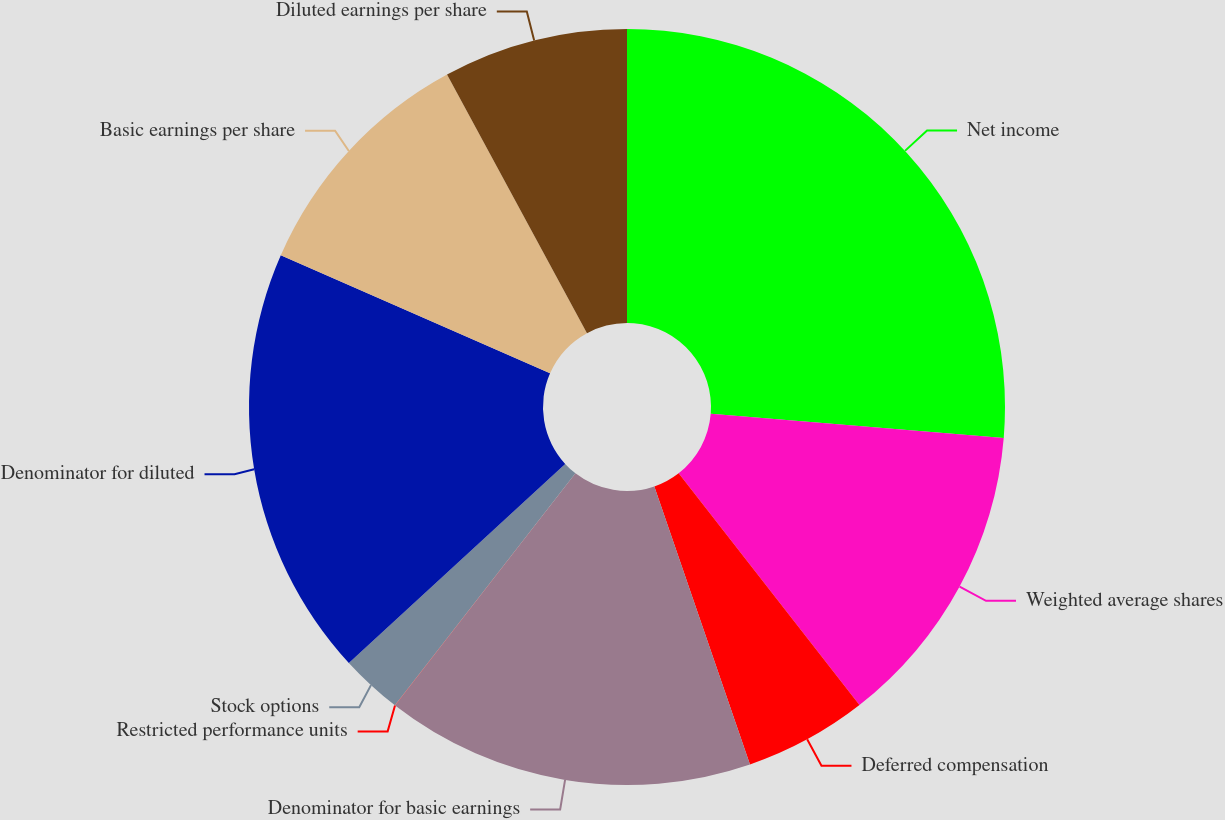Convert chart to OTSL. <chart><loc_0><loc_0><loc_500><loc_500><pie_chart><fcel>Net income<fcel>Weighted average shares<fcel>Deferred compensation<fcel>Denominator for basic earnings<fcel>Restricted performance units<fcel>Stock options<fcel>Denominator for diluted<fcel>Basic earnings per share<fcel>Diluted earnings per share<nl><fcel>26.31%<fcel>13.16%<fcel>5.27%<fcel>15.79%<fcel>0.01%<fcel>2.64%<fcel>18.42%<fcel>10.53%<fcel>7.9%<nl></chart> 